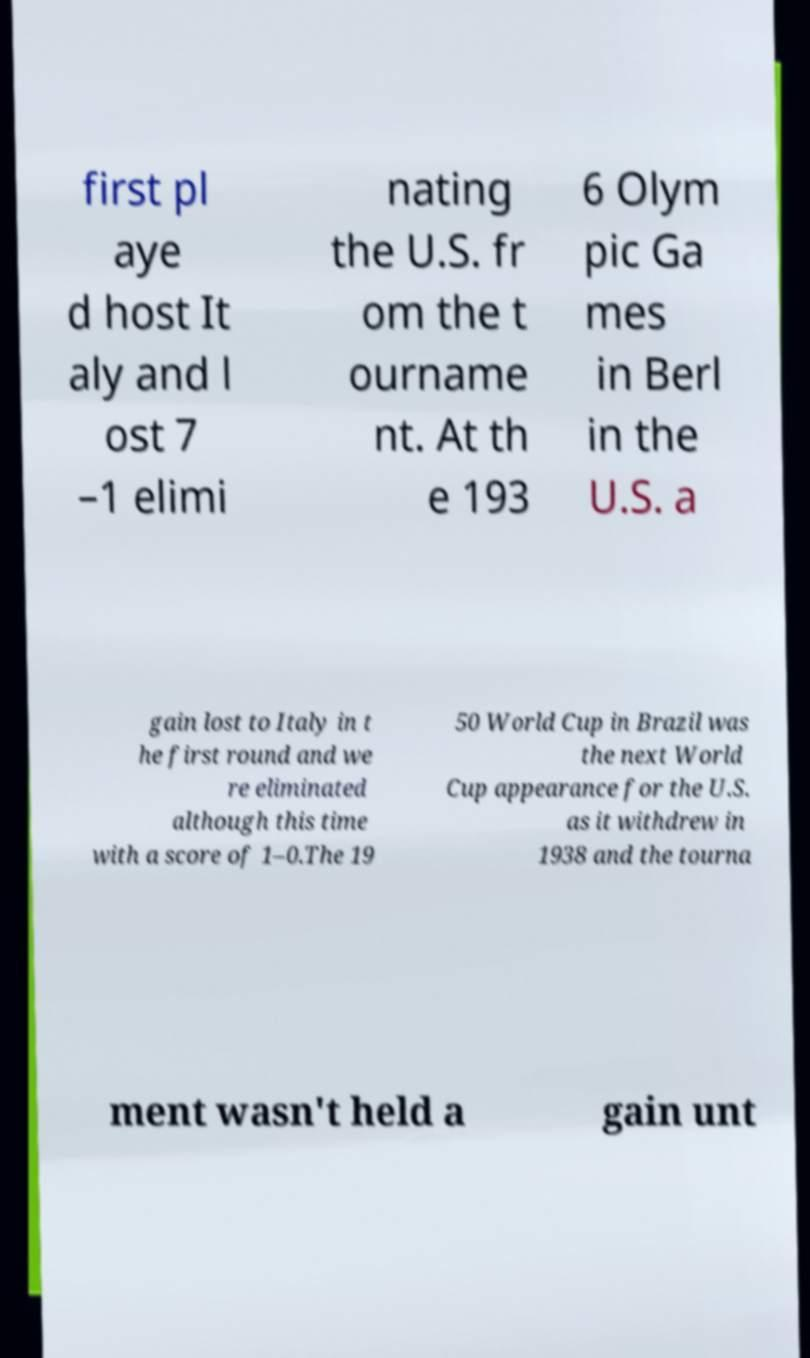What messages or text are displayed in this image? I need them in a readable, typed format. first pl aye d host It aly and l ost 7 –1 elimi nating the U.S. fr om the t ourname nt. At th e 193 6 Olym pic Ga mes in Berl in the U.S. a gain lost to Italy in t he first round and we re eliminated although this time with a score of 1–0.The 19 50 World Cup in Brazil was the next World Cup appearance for the U.S. as it withdrew in 1938 and the tourna ment wasn't held a gain unt 